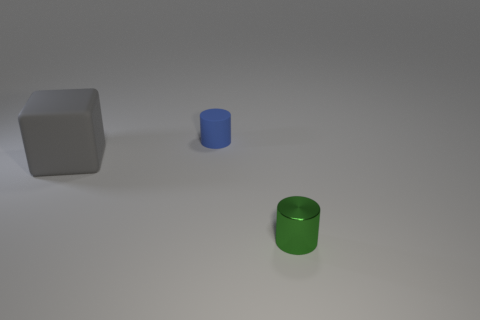Add 2 tiny green metal things. How many objects exist? 5 Subtract all green cylinders. How many cylinders are left? 1 Subtract all cylinders. How many objects are left? 1 Add 3 big gray matte cubes. How many big gray matte cubes exist? 4 Subtract 0 cyan spheres. How many objects are left? 3 Subtract all gray cylinders. Subtract all brown spheres. How many cylinders are left? 2 Subtract all big brown metallic cubes. Subtract all tiny green cylinders. How many objects are left? 2 Add 3 cylinders. How many cylinders are left? 5 